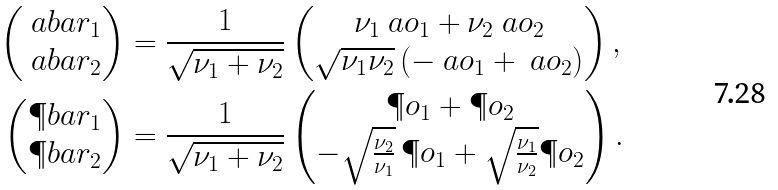<formula> <loc_0><loc_0><loc_500><loc_500>\begin{pmatrix} \ a b a r _ { 1 } \\ \ a b a r _ { 2 } \end{pmatrix} & = \frac { 1 } { \sqrt { \nu _ { 1 } + \nu _ { 2 } } } \begin{pmatrix} \nu _ { 1 } \ a o _ { 1 } + \nu _ { 2 } \ a o _ { 2 } \\ \sqrt { \nu _ { 1 } \nu _ { 2 } } \, ( - \ a o _ { 1 } + \ a o _ { 2 } ) \end{pmatrix} , \\ \begin{pmatrix} \P b a r _ { 1 } \\ \P b a r _ { 2 } \end{pmatrix} & = \frac { 1 } { \sqrt { \nu _ { 1 } + \nu _ { 2 } } } \begin{pmatrix} \P o _ { 1 } + \P o _ { 2 } \\ - \sqrt { \frac { \nu _ { 2 } } { \nu _ { 1 } } } \, \P o _ { 1 } + \sqrt { \frac { \nu _ { 1 } } { \nu _ { 2 } } } \P o _ { 2 } \end{pmatrix} .</formula> 